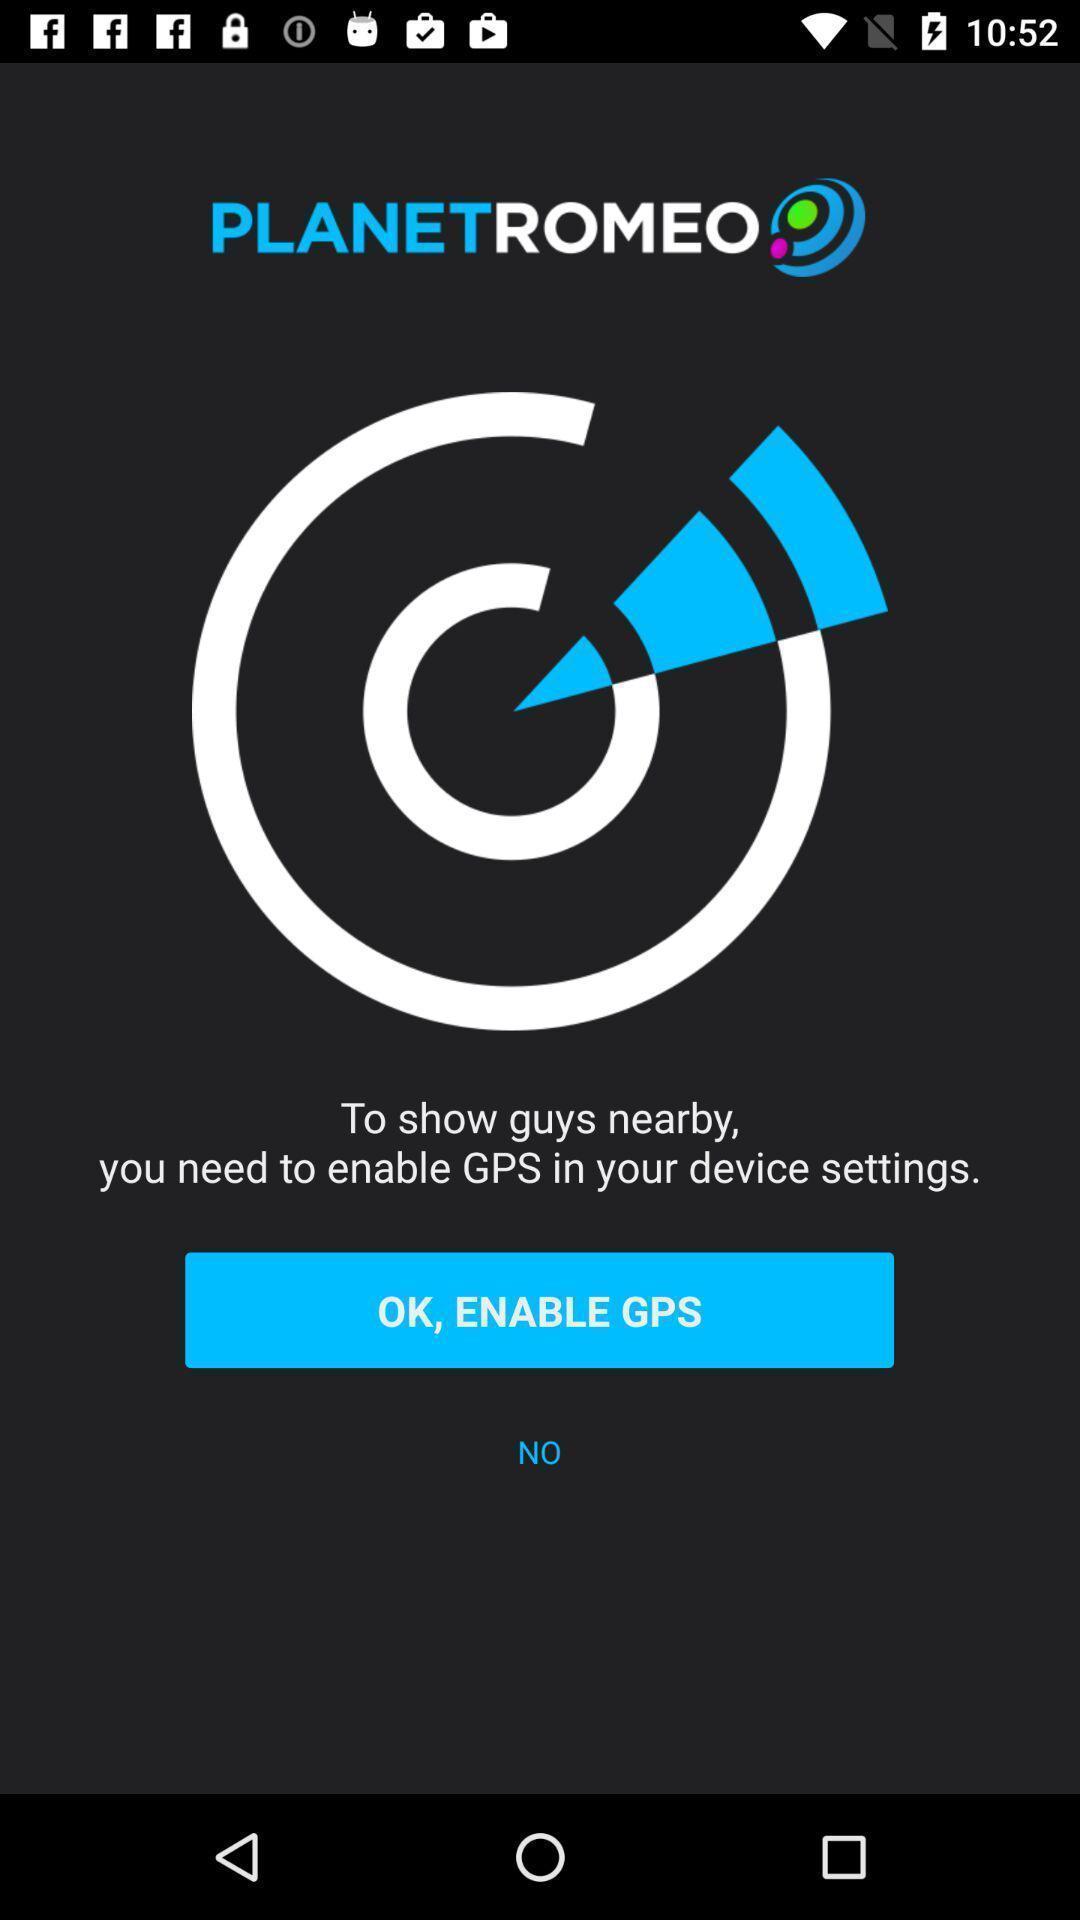What details can you identify in this image? Pay displaying to enable gps in app. 